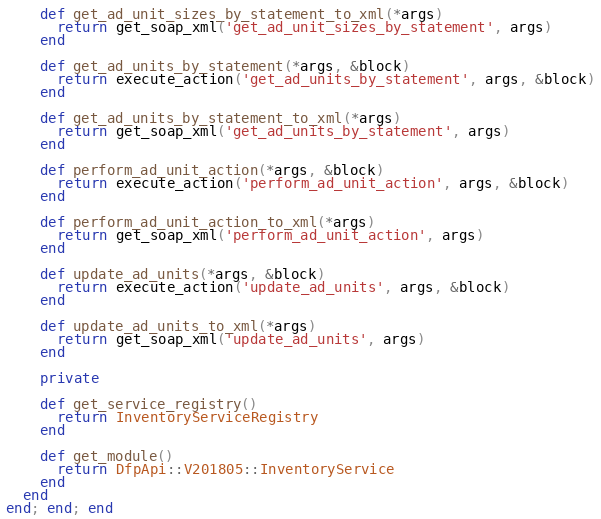Convert code to text. <code><loc_0><loc_0><loc_500><loc_500><_Ruby_>
    def get_ad_unit_sizes_by_statement_to_xml(*args)
      return get_soap_xml('get_ad_unit_sizes_by_statement', args)
    end

    def get_ad_units_by_statement(*args, &block)
      return execute_action('get_ad_units_by_statement', args, &block)
    end

    def get_ad_units_by_statement_to_xml(*args)
      return get_soap_xml('get_ad_units_by_statement', args)
    end

    def perform_ad_unit_action(*args, &block)
      return execute_action('perform_ad_unit_action', args, &block)
    end

    def perform_ad_unit_action_to_xml(*args)
      return get_soap_xml('perform_ad_unit_action', args)
    end

    def update_ad_units(*args, &block)
      return execute_action('update_ad_units', args, &block)
    end

    def update_ad_units_to_xml(*args)
      return get_soap_xml('update_ad_units', args)
    end

    private

    def get_service_registry()
      return InventoryServiceRegistry
    end

    def get_module()
      return DfpApi::V201805::InventoryService
    end
  end
end; end; end
</code> 